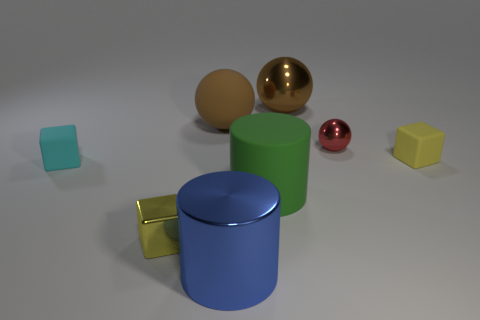Subtract all shiny blocks. How many blocks are left? 2 Subtract 1 spheres. How many spheres are left? 2 Add 2 small shiny cubes. How many objects exist? 10 Subtract all cubes. How many objects are left? 5 Add 7 small cyan cubes. How many small cyan cubes are left? 8 Add 6 yellow rubber cubes. How many yellow rubber cubes exist? 7 Subtract 0 green balls. How many objects are left? 8 Subtract all cyan matte blocks. Subtract all big brown metallic balls. How many objects are left? 6 